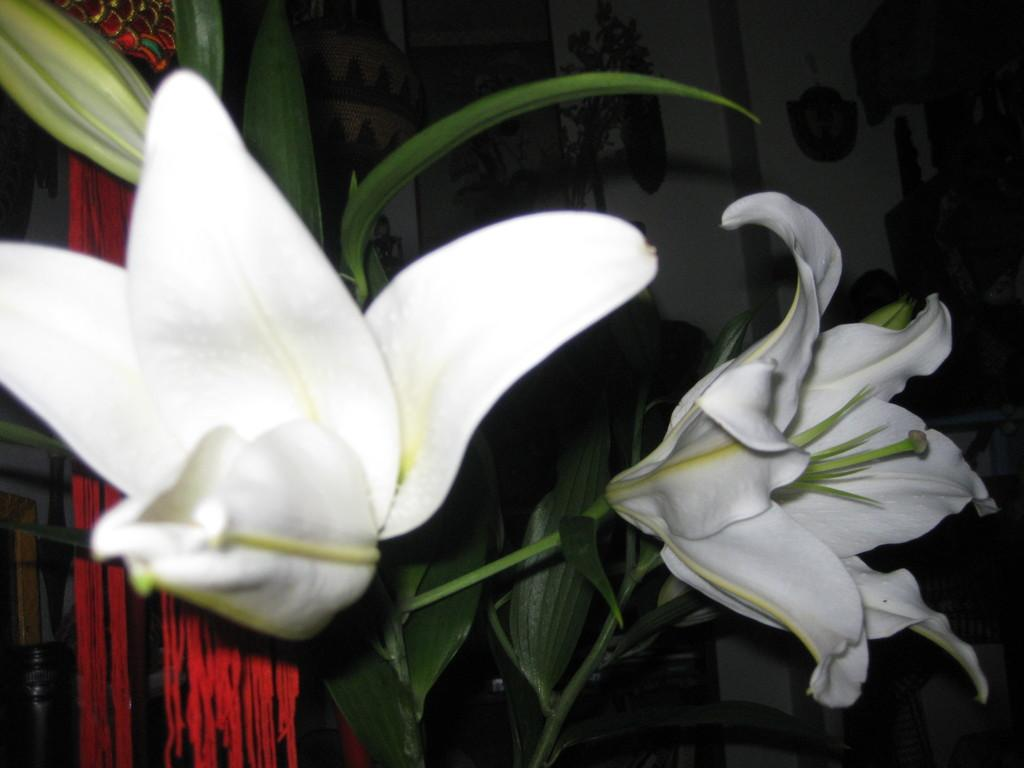What is the main subject of the image? The main subject of the image is plants and flowers. What color are the plants and flowers? The plants and flowers are white in color. What can be seen in the background of the image? There is a red cloth and a wooden object in the background of the image, along with a few other objects. What type of arithmetic problem can be solved using the plants and flowers in the image? There is no arithmetic problem present in the image, as it features plants and flowers. Can you hear any acoustic sounds coming from the plants and flowers in the image? There are no acoustic sounds associated with the plants and flowers in the image, as they are not capable of producing sound. 